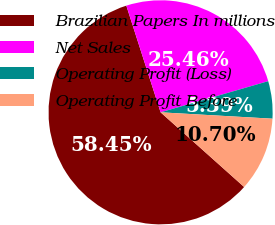<chart> <loc_0><loc_0><loc_500><loc_500><pie_chart><fcel>Brazilian Papers In millions<fcel>Net Sales<fcel>Operating Profit (Loss)<fcel>Operating Profit Before<nl><fcel>58.44%<fcel>25.46%<fcel>5.39%<fcel>10.7%<nl></chart> 